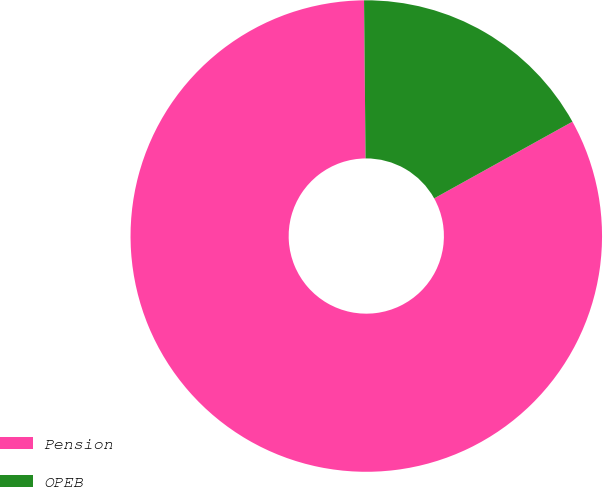Convert chart to OTSL. <chart><loc_0><loc_0><loc_500><loc_500><pie_chart><fcel>Pension<fcel>OPEB<nl><fcel>82.91%<fcel>17.09%<nl></chart> 